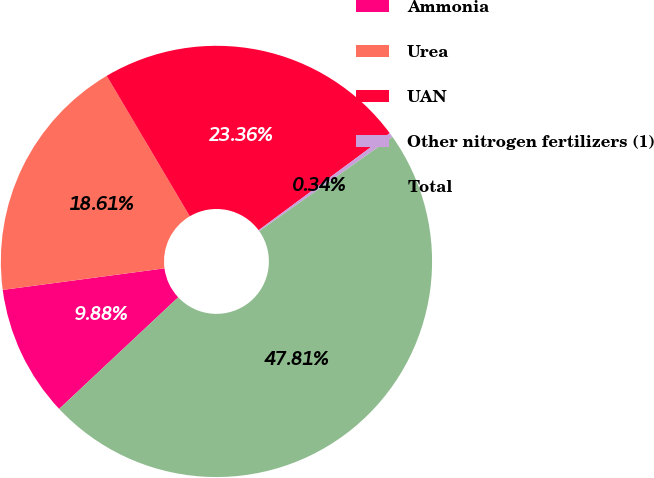Convert chart to OTSL. <chart><loc_0><loc_0><loc_500><loc_500><pie_chart><fcel>Ammonia<fcel>Urea<fcel>UAN<fcel>Other nitrogen fertilizers (1)<fcel>Total<nl><fcel>9.88%<fcel>18.61%<fcel>23.36%<fcel>0.34%<fcel>47.81%<nl></chart> 